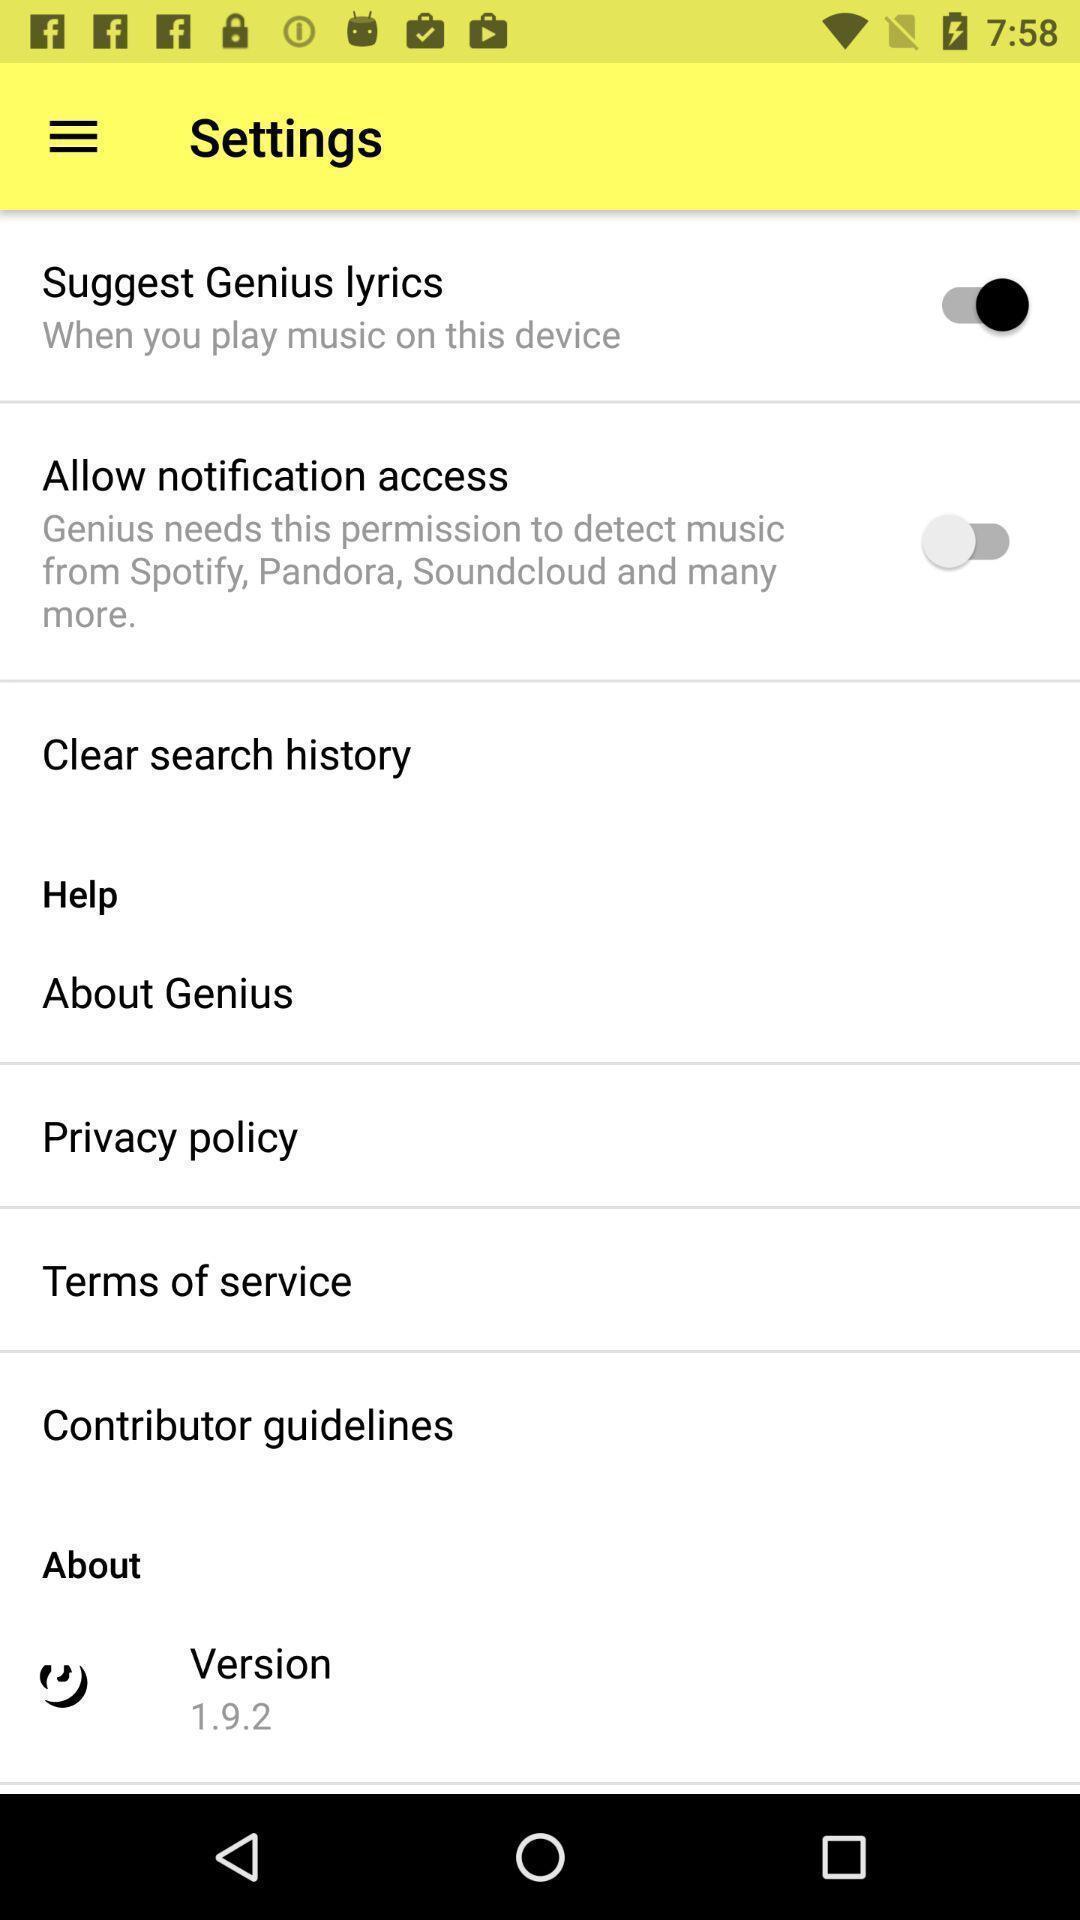Give me a narrative description of this picture. Screen showing settings options. 